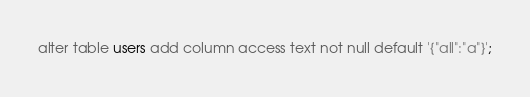<code> <loc_0><loc_0><loc_500><loc_500><_SQL_>alter table users add column access text not null default '{"all":"a"}';
</code> 